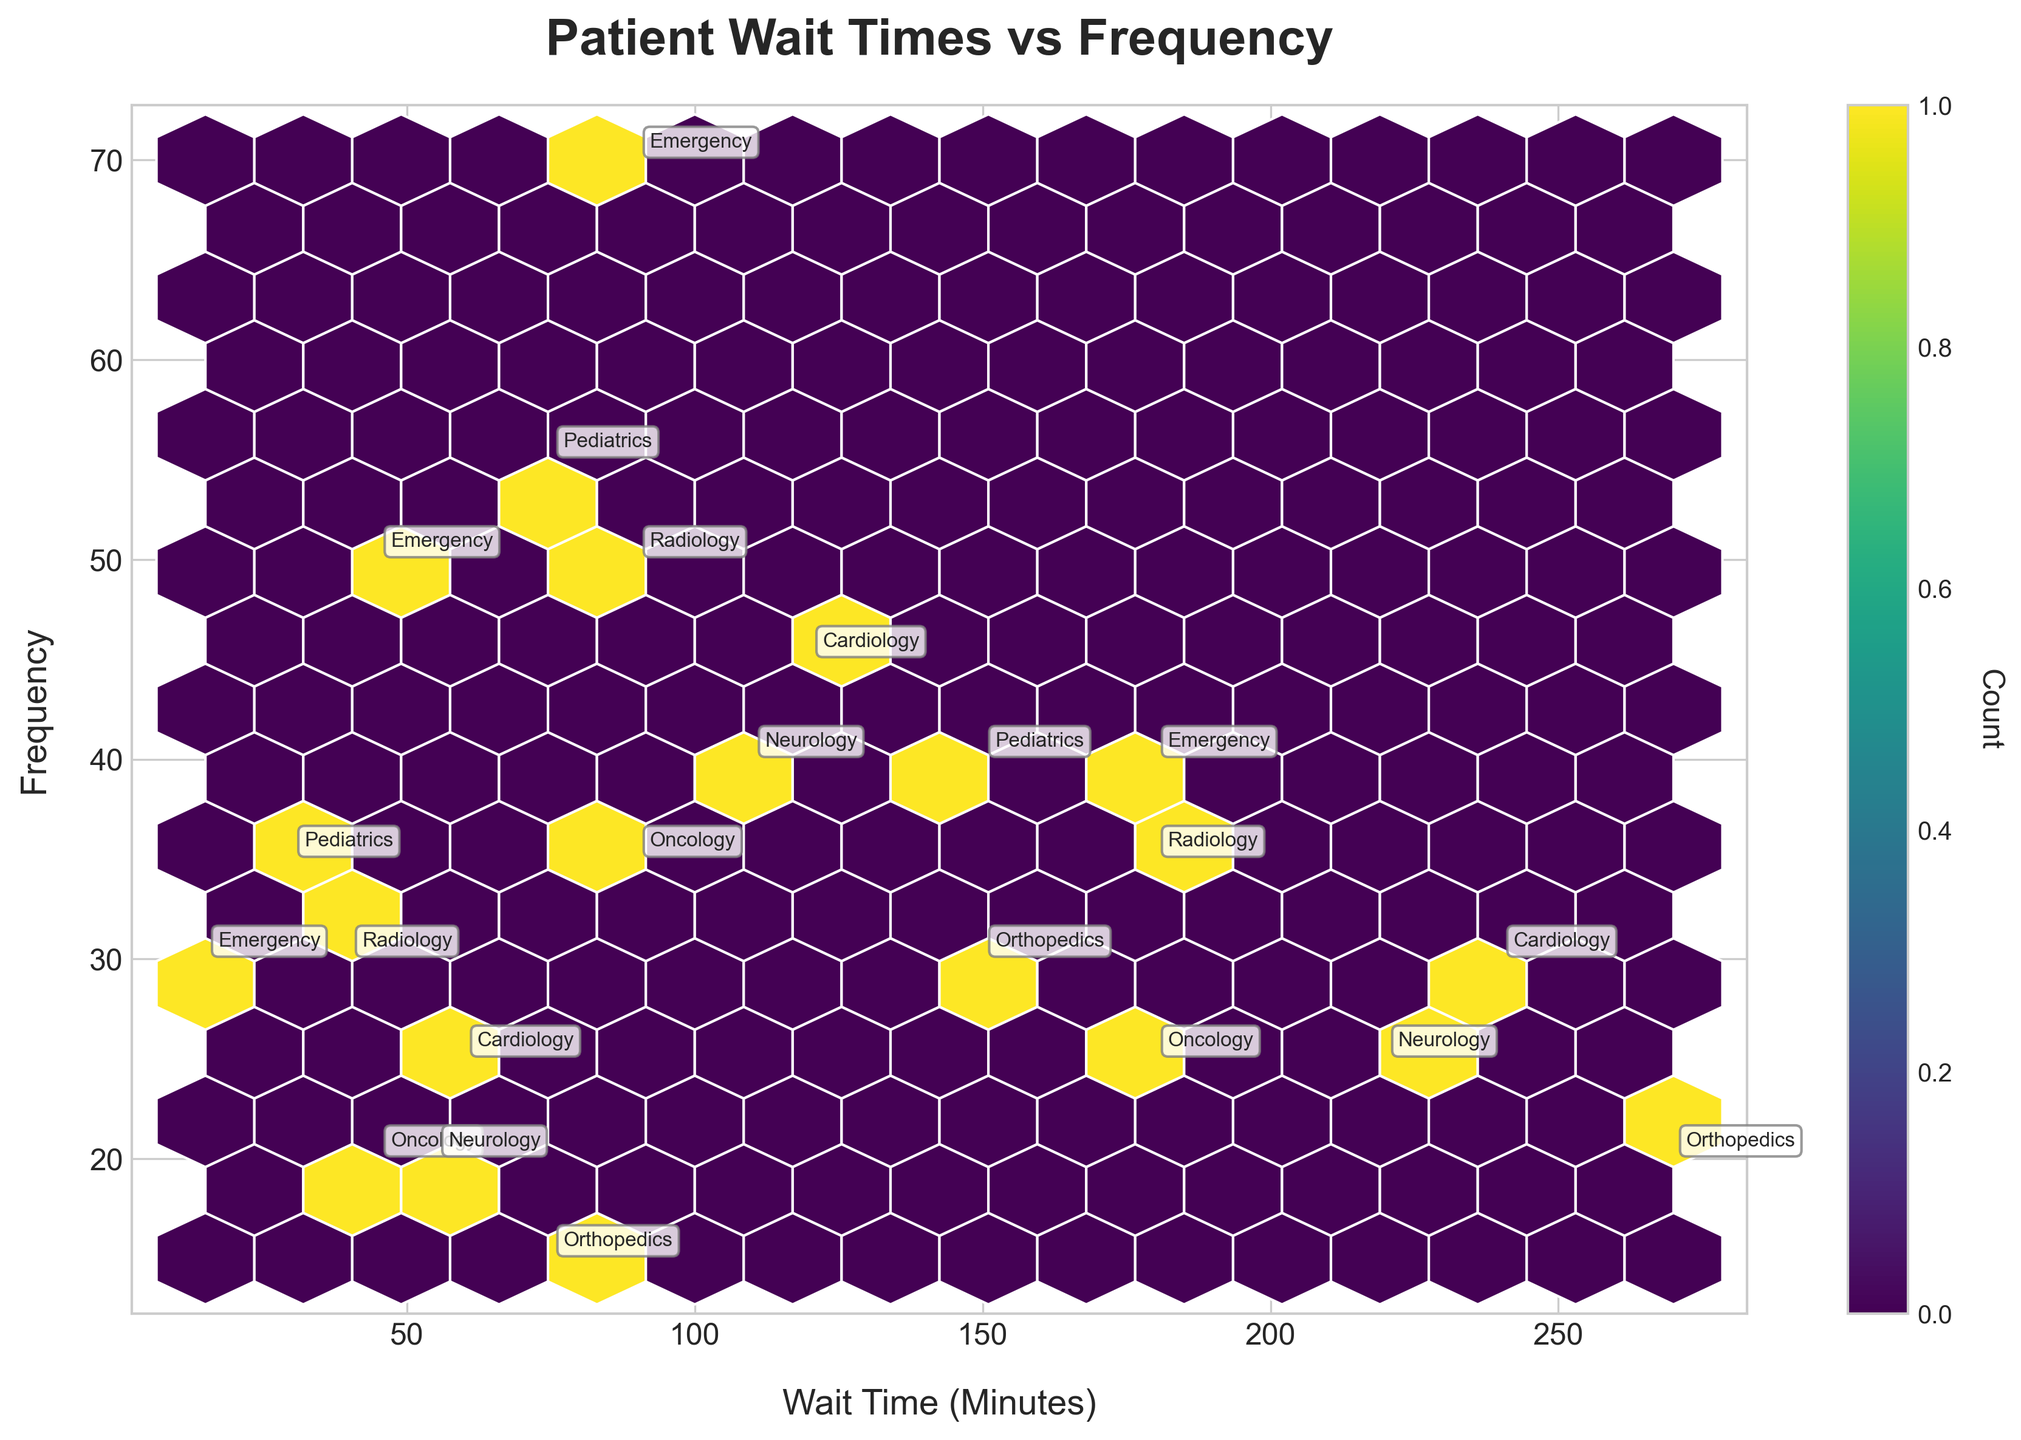What is the title of the figure? The title is prominently displayed at the top of the plot, designed to clearly state the main focus of the visualization.
Answer: Patient Wait Times vs Frequency What is the range of wait times shown on the x-axis? By looking at the x-axis labels, you can see it spans from the minimum to maximum displayed wait times.
Answer: 15 to 270 minutes Which department has the highest wait time for the 'Low' urgency level? By following the labels on the plot, the department with the highest wait time for 'Low' urgency level can be identified.
Answer: Orthopedics How many departments have a wait time of at least 180 minutes for the 'Low' urgency level? Locate the 'Low' urgency level points in the plot and count the departments with wait times of 180 minutes or more.
Answer: Three departments What is the color representing the highest density of data points? The color bar adjacent to the plot shows the corresponding colors for different densities, where the color representing the highest density can be seen.
Answer: Dark purple Between Pediatrics and Neurology, which department has a lower average wait time for the 'High' urgency level? Identify the 'High' urgency level wait times for both departments, then calculate and compare their averages.
Answer: Pediatrics Which urgency level seems to exhibit the widest range of wait times across all departments? By comparing the spread of wait times (the range) for each urgency level, determine which one spans the widest interval.
Answer: Low How does the frequency distribution of 'Medium' urgency levels compare between Oncology and Radiology? Locate the wait times and frequencies for 'Medium' urgency in both Oncology and Radiology to compare their distributions.
Answer: Radiology has a higher frequency for 'Medium' urgency Which department has the closest frequency for 'High' urgency levels to the Emergency department? Compare the frequencies of 'High' urgency levels for each department against the data for the Emergency department.
Answer: Radiology 